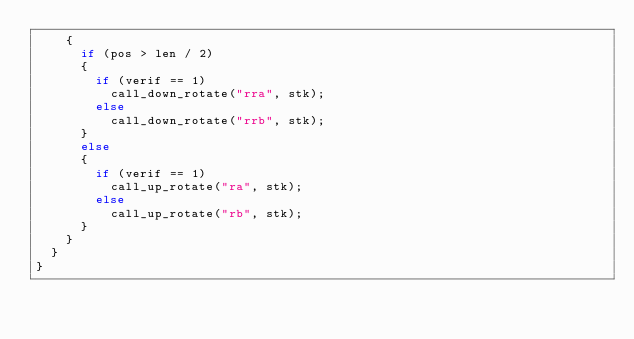<code> <loc_0><loc_0><loc_500><loc_500><_C_>		{
			if (pos > len / 2)
			{
				if (verif == 1)
					call_down_rotate("rra", stk);
				else
					call_down_rotate("rrb", stk);
			}
			else
			{
				if (verif == 1)
					call_up_rotate("ra", stk);
				else
					call_up_rotate("rb", stk);
			}
		}
	}
}
</code> 